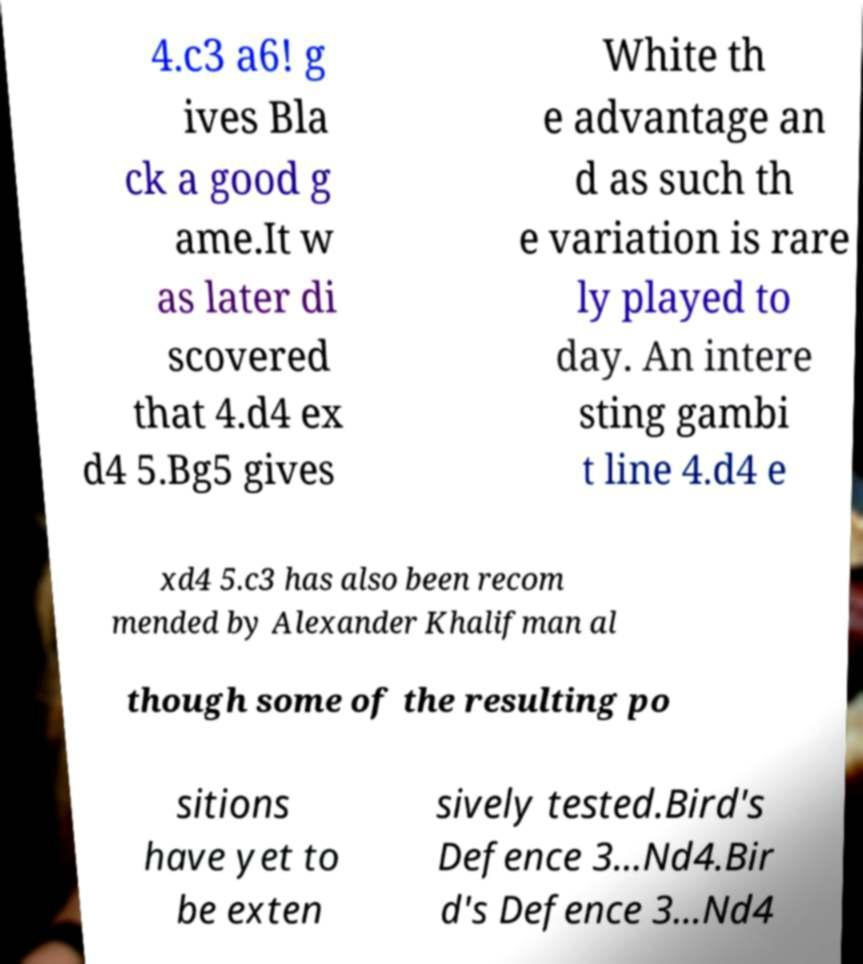For documentation purposes, I need the text within this image transcribed. Could you provide that? 4.c3 a6! g ives Bla ck a good g ame.It w as later di scovered that 4.d4 ex d4 5.Bg5 gives White th e advantage an d as such th e variation is rare ly played to day. An intere sting gambi t line 4.d4 e xd4 5.c3 has also been recom mended by Alexander Khalifman al though some of the resulting po sitions have yet to be exten sively tested.Bird's Defence 3...Nd4.Bir d's Defence 3...Nd4 